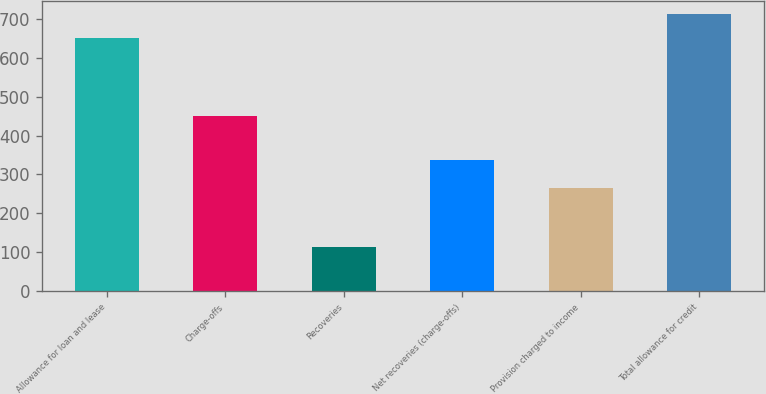Convert chart. <chart><loc_0><loc_0><loc_500><loc_500><bar_chart><fcel>Allowance for loan and lease<fcel>Charge-offs<fcel>Recoveries<fcel>Net recoveries (charge-offs)<fcel>Provision charged to income<fcel>Total allowance for credit<nl><fcel>651<fcel>450<fcel>112<fcel>338<fcel>266<fcel>712.1<nl></chart> 